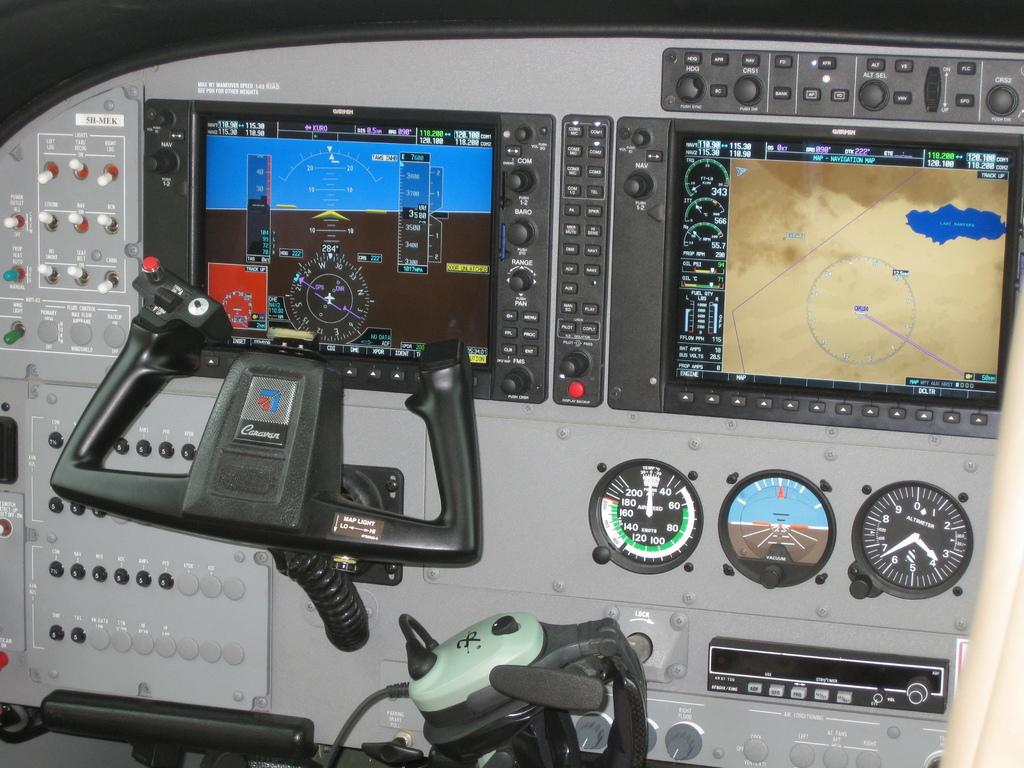<image>
Summarize the visual content of the image. The aircraft controls say Caravan on the control stick. 